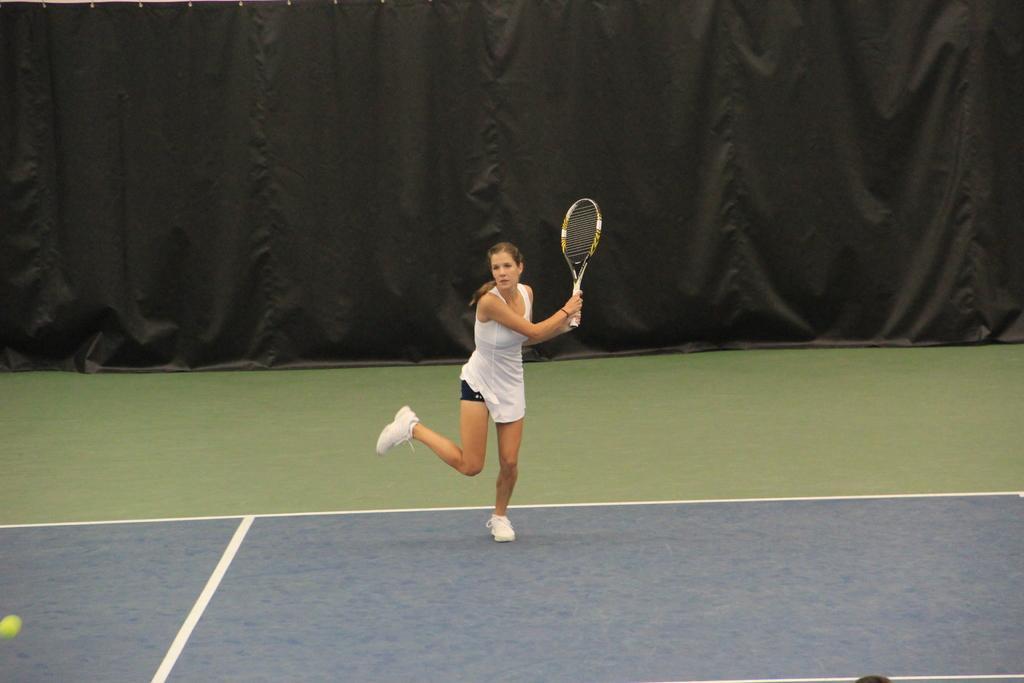Describe this image in one or two sentences. This image is clicked in a tennis court. There is a woman playing tennis. She is wearing white dress and white shoes. In the background, there is a black cloth. 